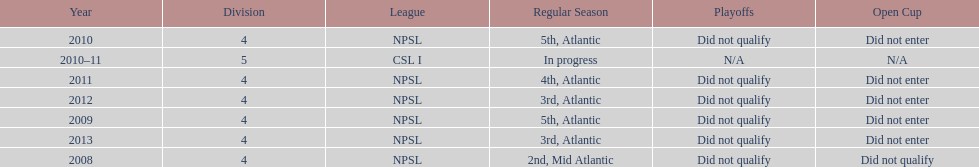How many years did they not qualify for the playoffs? 6. 